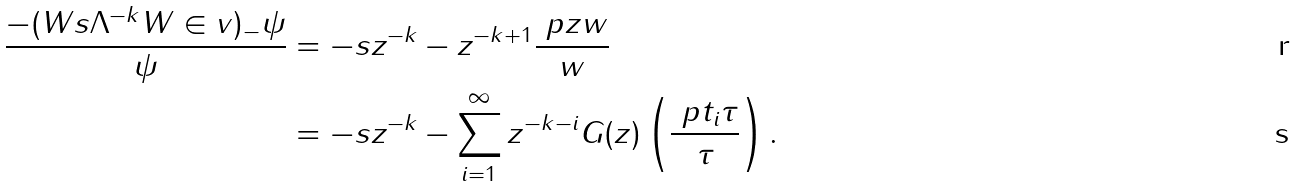<formula> <loc_0><loc_0><loc_500><loc_500>\frac { - ( W s \Lambda ^ { - k } W \in v ) _ { - } \psi } \psi & = - s z ^ { - k } - z ^ { - k + 1 } \frac { \ p { z } w } w \\ & = - s z ^ { - k } - \sum _ { i = 1 } ^ { \infty } z ^ { - k - i } G ( z ) \left ( \frac { \ p { t _ { i } } \tau } \tau \right ) .</formula> 